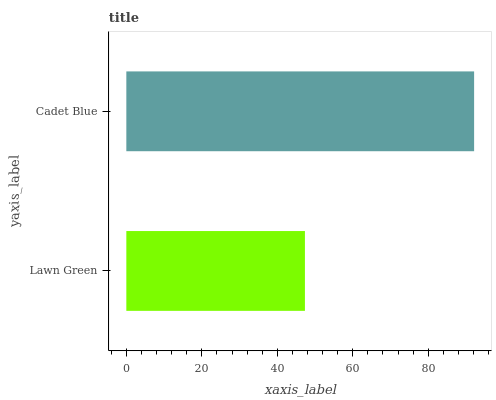Is Lawn Green the minimum?
Answer yes or no. Yes. Is Cadet Blue the maximum?
Answer yes or no. Yes. Is Cadet Blue the minimum?
Answer yes or no. No. Is Cadet Blue greater than Lawn Green?
Answer yes or no. Yes. Is Lawn Green less than Cadet Blue?
Answer yes or no. Yes. Is Lawn Green greater than Cadet Blue?
Answer yes or no. No. Is Cadet Blue less than Lawn Green?
Answer yes or no. No. Is Cadet Blue the high median?
Answer yes or no. Yes. Is Lawn Green the low median?
Answer yes or no. Yes. Is Lawn Green the high median?
Answer yes or no. No. Is Cadet Blue the low median?
Answer yes or no. No. 